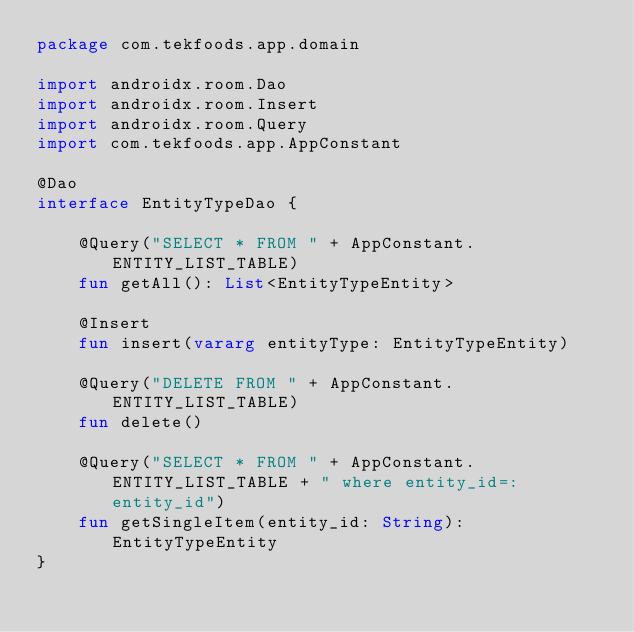Convert code to text. <code><loc_0><loc_0><loc_500><loc_500><_Kotlin_>package com.tekfoods.app.domain

import androidx.room.Dao
import androidx.room.Insert
import androidx.room.Query
import com.tekfoods.app.AppConstant

@Dao
interface EntityTypeDao {

    @Query("SELECT * FROM " + AppConstant.ENTITY_LIST_TABLE)
    fun getAll(): List<EntityTypeEntity>

    @Insert
    fun insert(vararg entityType: EntityTypeEntity)

    @Query("DELETE FROM " + AppConstant.ENTITY_LIST_TABLE)
    fun delete()

    @Query("SELECT * FROM " + AppConstant.ENTITY_LIST_TABLE + " where entity_id=:entity_id")
    fun getSingleItem(entity_id: String): EntityTypeEntity
}</code> 